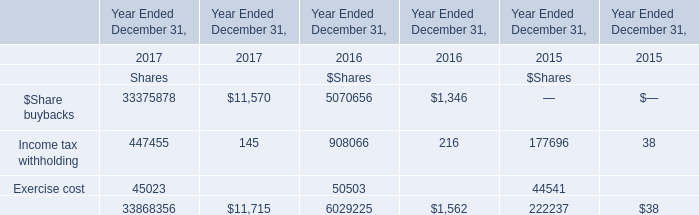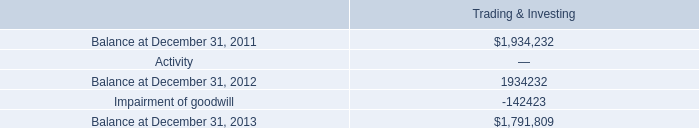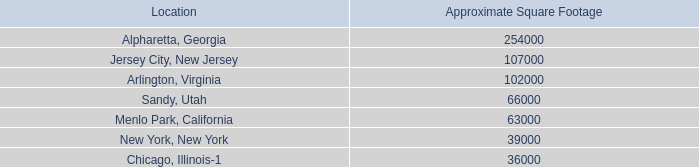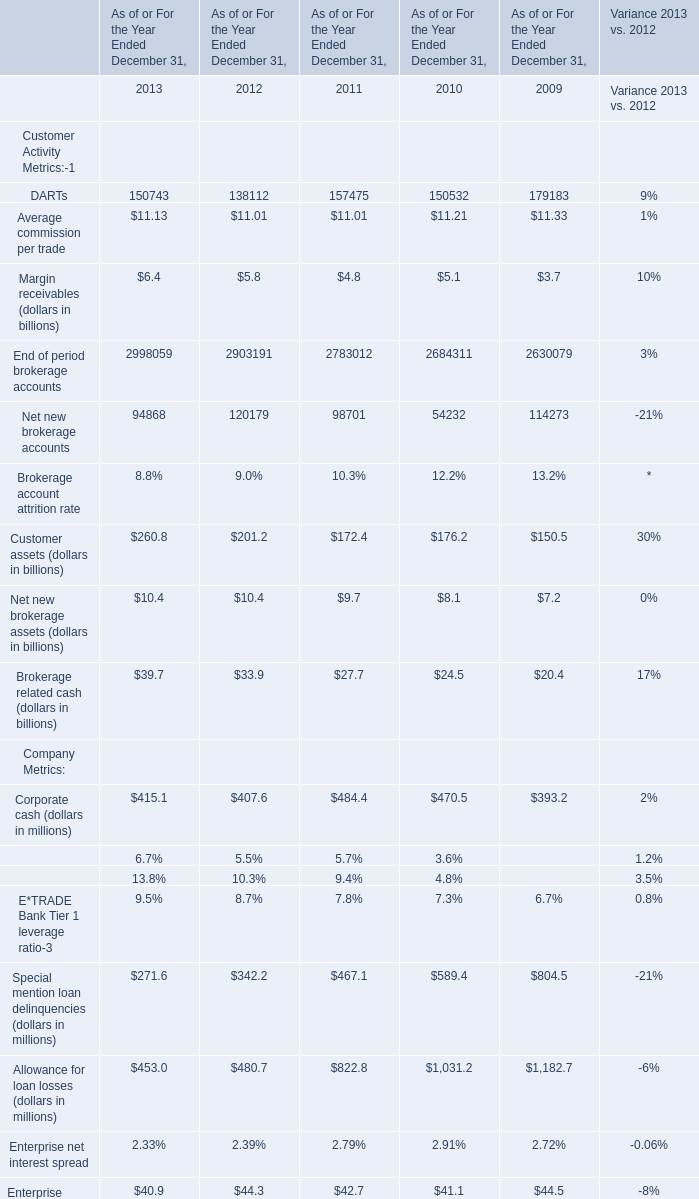Which year is Average commission per trade the most? 
Answer: 2009. 